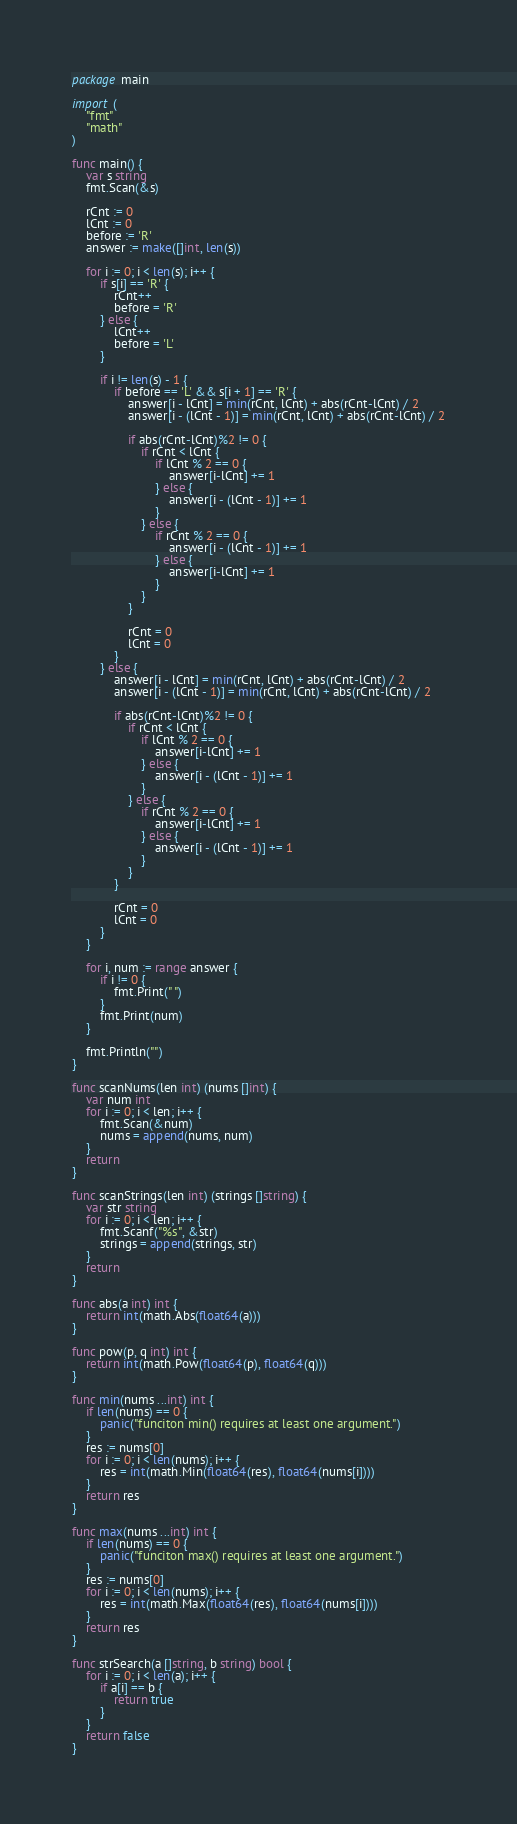<code> <loc_0><loc_0><loc_500><loc_500><_Go_>package main

import (
	"fmt"
	"math"
)

func main() {
	var s string
	fmt.Scan(&s)

	rCnt := 0
	lCnt := 0
	before := 'R'
	answer := make([]int, len(s))

	for i := 0; i < len(s); i++ {
		if s[i] == 'R' {
			rCnt++
			before = 'R'
		} else {
			lCnt++
			before = 'L'
		}

		if i != len(s) - 1 {
			if before == 'L' && s[i + 1] == 'R' {
				answer[i - lCnt] = min(rCnt, lCnt) + abs(rCnt-lCnt) / 2
				answer[i - (lCnt - 1)] = min(rCnt, lCnt) + abs(rCnt-lCnt) / 2

				if abs(rCnt-lCnt)%2 != 0 {
					if rCnt < lCnt {
						if lCnt % 2 == 0 {
							answer[i-lCnt] += 1
						} else {
							answer[i - (lCnt - 1)] += 1
						}
					} else {
						if rCnt % 2 == 0 {
							answer[i - (lCnt - 1)] += 1
						} else {
							answer[i-lCnt] += 1
						}
					}
				}

				rCnt = 0
				lCnt = 0
			}
		} else {
			answer[i - lCnt] = min(rCnt, lCnt) + abs(rCnt-lCnt) / 2
			answer[i - (lCnt - 1)] = min(rCnt, lCnt) + abs(rCnt-lCnt) / 2

			if abs(rCnt-lCnt)%2 != 0 {
				if rCnt < lCnt {
					if lCnt % 2 == 0 {
						answer[i-lCnt] += 1
					} else {
						answer[i - (lCnt - 1)] += 1
					}
				} else {
					if rCnt % 2 == 0 {
						answer[i-lCnt] += 1
					} else {
						answer[i - (lCnt - 1)] += 1
					}
				}
			}

			rCnt = 0
			lCnt = 0
		}
	}

	for i, num := range answer {
		if i != 0 {
			fmt.Print(" ")
		}
		fmt.Print(num)
	}

	fmt.Println("")
}

func scanNums(len int) (nums []int) {
	var num int
	for i := 0; i < len; i++ {
		fmt.Scan(&num)
		nums = append(nums, num)
	}
	return
}

func scanStrings(len int) (strings []string) {
	var str string
	for i := 0; i < len; i++ {
		fmt.Scanf("%s", &str)
		strings = append(strings, str)
	}
	return
}

func abs(a int) int {
	return int(math.Abs(float64(a)))
}

func pow(p, q int) int {
	return int(math.Pow(float64(p), float64(q)))
}

func min(nums ...int) int {
	if len(nums) == 0 {
		panic("funciton min() requires at least one argument.")
	}
	res := nums[0]
	for i := 0; i < len(nums); i++ {
		res = int(math.Min(float64(res), float64(nums[i])))
	}
	return res
}

func max(nums ...int) int {
	if len(nums) == 0 {
		panic("funciton max() requires at least one argument.")
	}
	res := nums[0]
	for i := 0; i < len(nums); i++ {
		res = int(math.Max(float64(res), float64(nums[i])))
	}
	return res
}

func strSearch(a []string, b string) bool {
	for i := 0; i < len(a); i++ {
		if a[i] == b {
			return true
		}
	}
	return false
}
</code> 